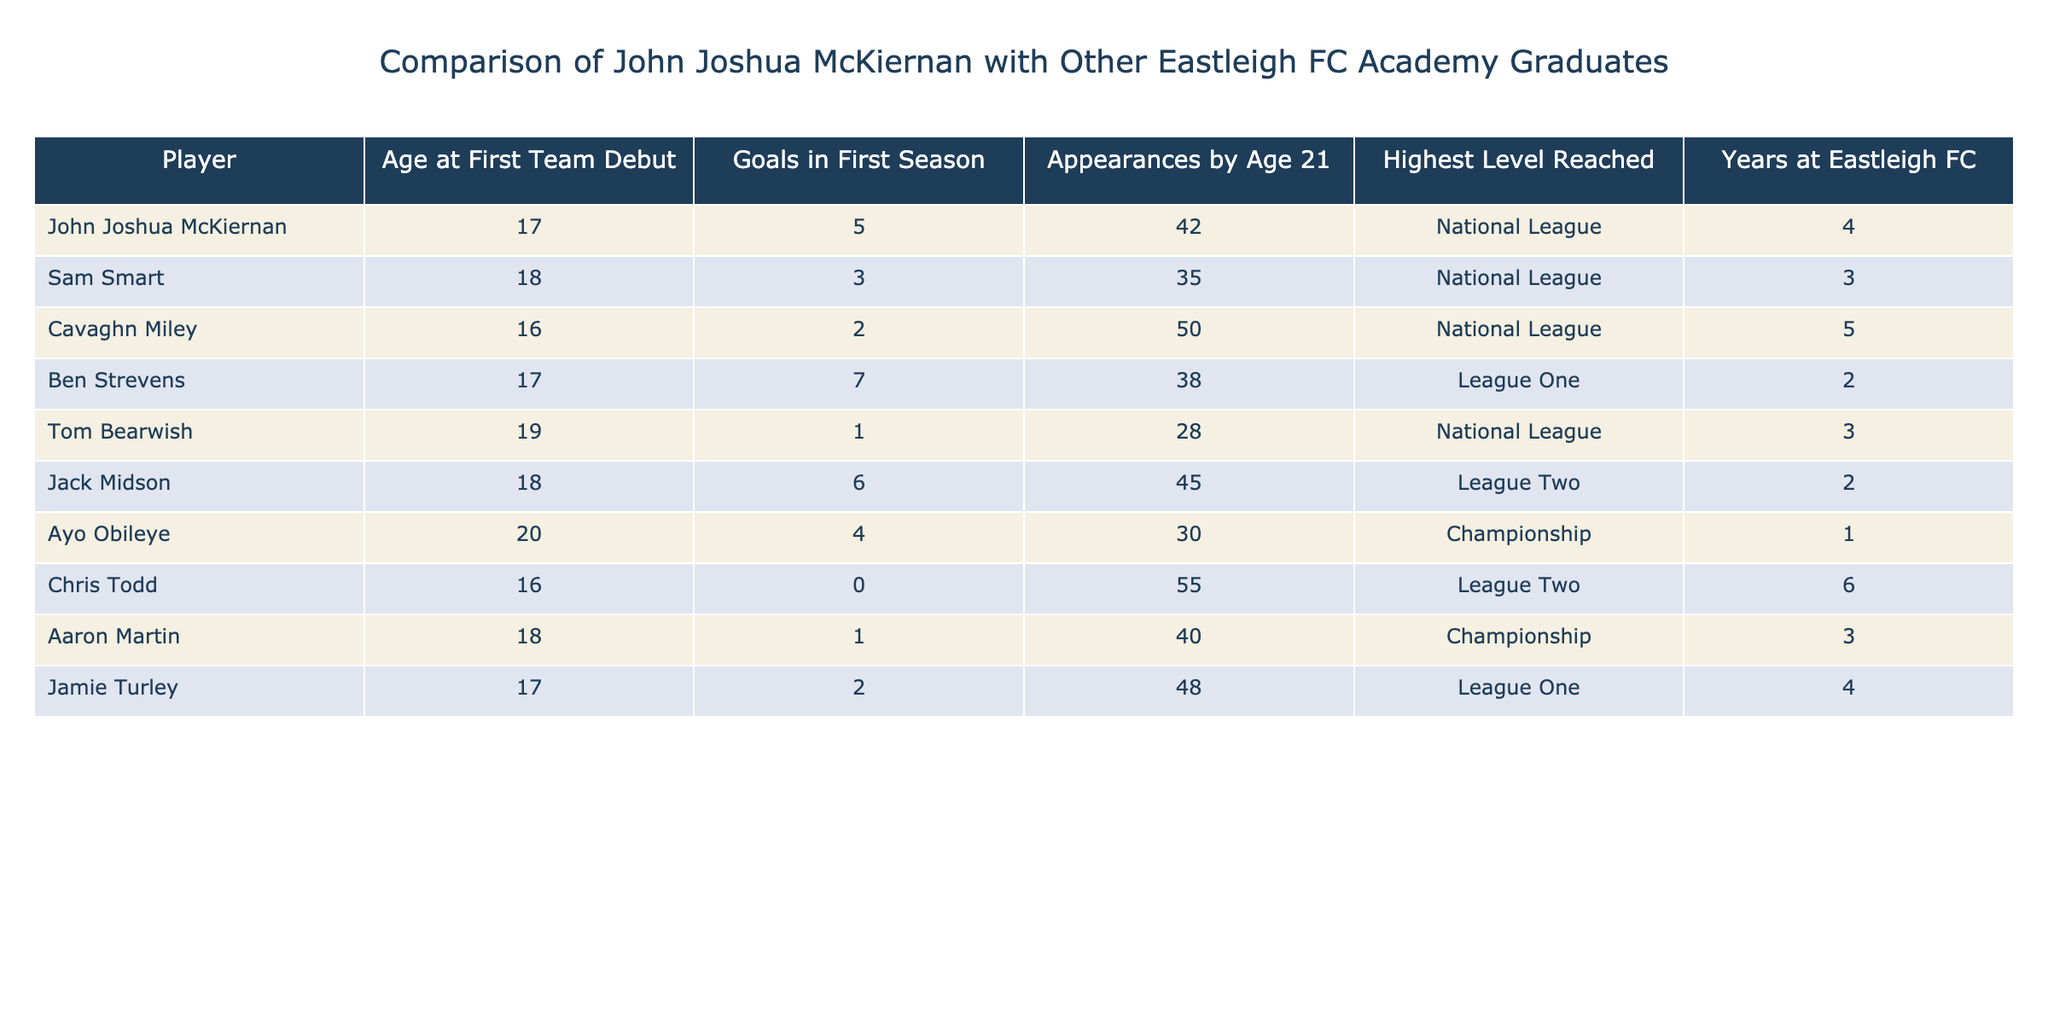What is the age of John Joshua McKiernan at his first team debut? According to the table, John Joshua McKiernan made his first team debut at the age of 17.
Answer: 17 How many goals did Sam Smart score in his first season? The data shows that Sam Smart scored 3 goals in his first season.
Answer: 3 Who has the highest number of appearances by the age of 21? By checking the appearances listed, Cavaghn Miley has the highest number of appearances at 50 by the age of 21.
Answer: Cavaghn Miley What was the highest level reached by Ben Strevens? The table indicates that Ben Strevens reached the League One level in his career.
Answer: League One What is the average number of goals scored in the first season by all players listed? The total number of goals scored in the first season by all players is 5+3+2+7+1+6+4+0+1+2 = 31, and there are 10 players, so the average is 31/10 = 3.1.
Answer: 3.1 Is it true that Ayo Obileye played for Eastleigh FC for more than one year? Looking at the table, Ayo Obileye only spent 1 year at Eastleigh FC, which makes this statement false.
Answer: False How many players scored more than 5 goals in their first season? The players who scored more than 5 goals are John Joshua McKiernan and Ben Strevens (who scored 7). Therefore, there are 2 players.
Answer: 2 Who has the most years at Eastleigh FC among the players listed? By analyzing the years column, Chris Todd has the most years at 6 years with Eastleigh FC.
Answer: Chris Todd What is the difference in appearances by age 21 between John Joshua McKiernan and Jamie Turley? John Joshua McKiernan has 42 appearances by age 21 and Jamie Turley has 48. The difference is 48 - 42 = 6.
Answer: 6 Which player had the fewest appearances by the age of 21, and how many were they? By checking the table, Tom Bearwish had the fewest appearances by age 21 at 28.
Answer: Tom Bearwish; 28 What level did Cavaghn Miley reach and how does it compare to John Joshua McKiernan's highest level? Cavaghn Miley reached the National League, while John Joshua McKiernan also reached the National League. Both levels are the same.
Answer: Same level: National League 